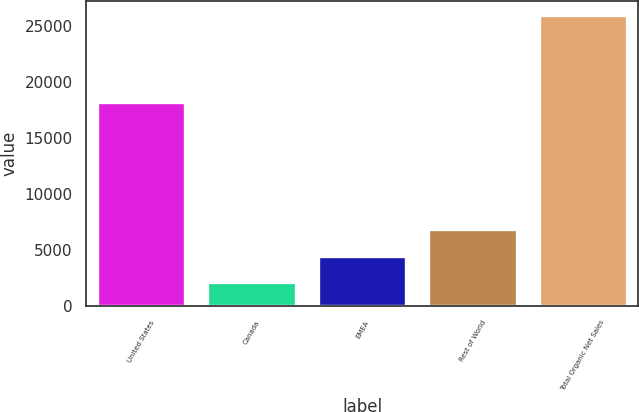<chart> <loc_0><loc_0><loc_500><loc_500><bar_chart><fcel>United States<fcel>Canada<fcel>EMEA<fcel>Rest of World<fcel>Total Organic Net Sales<nl><fcel>18230<fcel>2135<fcel>4517.8<fcel>6900.6<fcel>25963<nl></chart> 